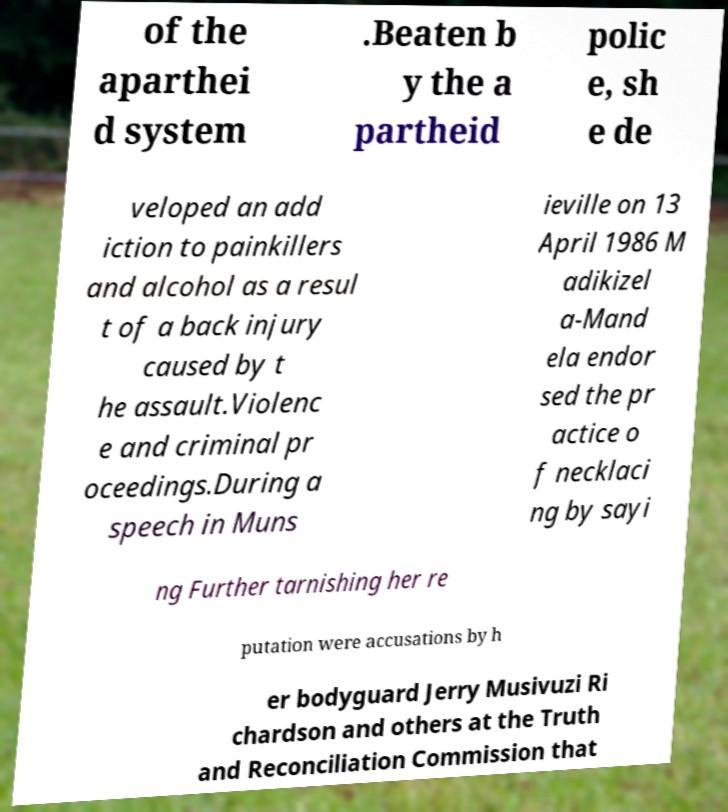What messages or text are displayed in this image? I need them in a readable, typed format. of the aparthei d system .Beaten b y the a partheid polic e, sh e de veloped an add iction to painkillers and alcohol as a resul t of a back injury caused by t he assault.Violenc e and criminal pr oceedings.During a speech in Muns ieville on 13 April 1986 M adikizel a-Mand ela endor sed the pr actice o f necklaci ng by sayi ng Further tarnishing her re putation were accusations by h er bodyguard Jerry Musivuzi Ri chardson and others at the Truth and Reconciliation Commission that 